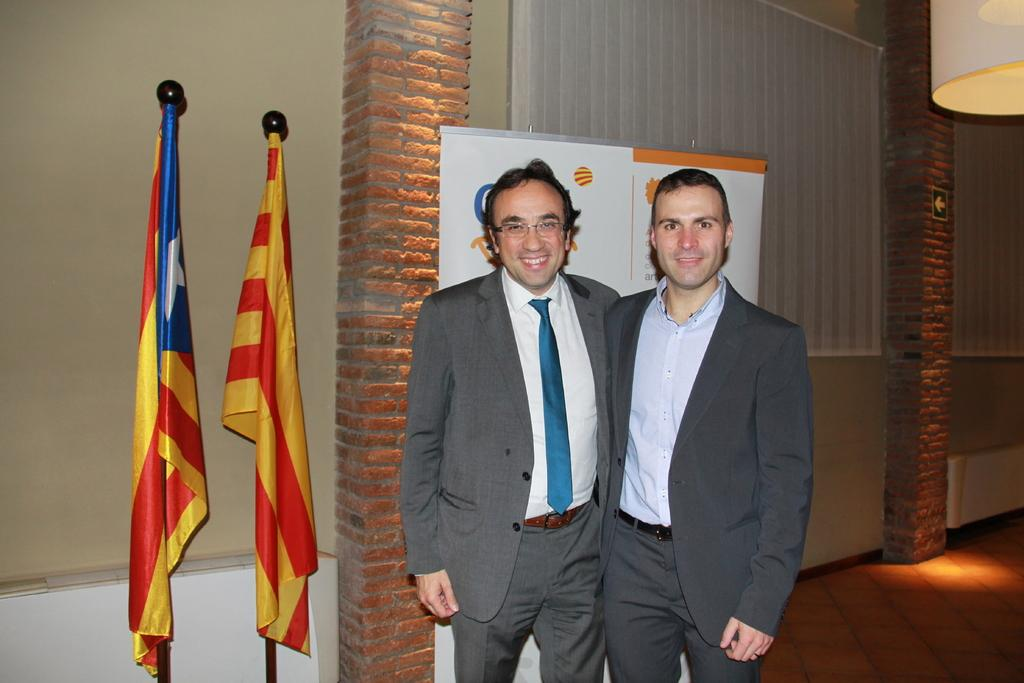How many people are in the image? There are two men standing in the image. What can be seen on the left side of the image? There are two flags on the left side of the image. What is visible in the background of the image? There is a wall in the background of the image. Can you describe the lighting in the image? There is a light in the image. What type of flower is being taught to the men in the image? There is no flower or teaching activity present in the image. How much muscle mass do the men have in the image? The image does not provide information about the men's muscle mass. 